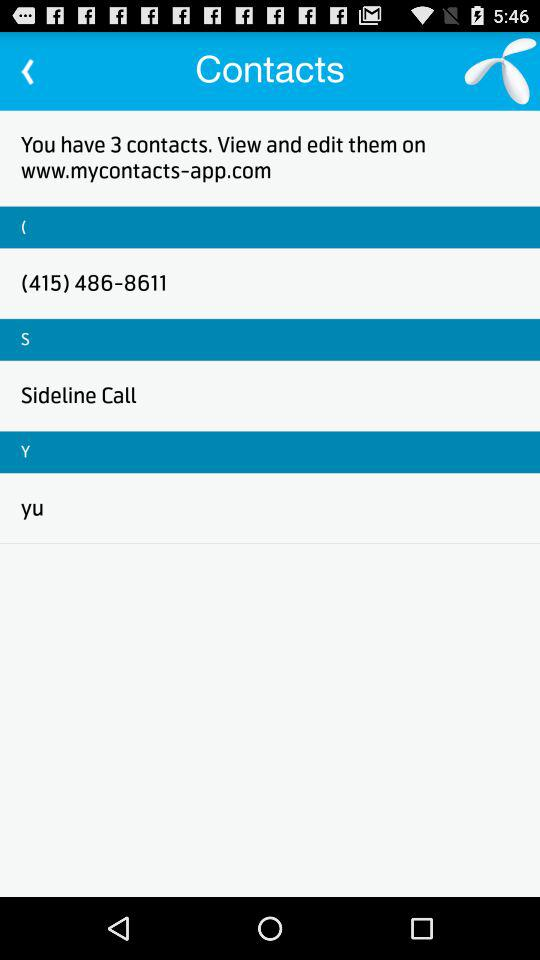What is the phone number of "Sideline Call"?
When the provided information is insufficient, respond with <no answer>. <no answer> 